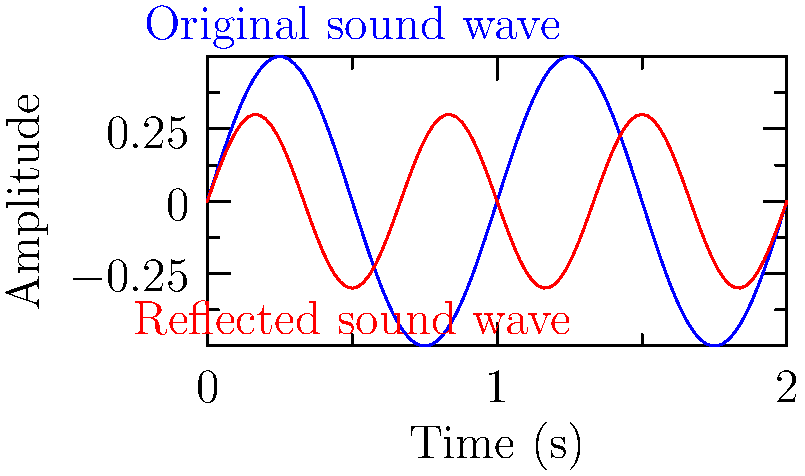In a theater, you're analyzing the acoustics represented by the sound wave diagram above. The blue wave represents the original sound, and the red wave represents the reflected sound. If the original sound has a frequency of 440 Hz, what is the frequency of the reflected sound wave? To solve this problem, we need to analyze the relationship between the two waves:

1. Observe that the blue wave (original sound) completes 2 full cycles in the given time frame.
2. The red wave (reflected sound) completes 3 full cycles in the same time frame.
3. The ratio of their frequencies will be proportional to the number of cycles completed:

   $\frac{f_{\text{reflected}}}{f_{\text{original}}} = \frac{3}{2}$

4. We know that $f_{\text{original}} = 440$ Hz, so we can set up the equation:

   $\frac{f_{\text{reflected}}}{440} = \frac{3}{2}$

5. Cross-multiply:

   $2f_{\text{reflected}} = 3 \times 440$

6. Solve for $f_{\text{reflected}}$:

   $f_{\text{reflected}} = \frac{3 \times 440}{2} = 660$ Hz

Therefore, the frequency of the reflected sound wave is 660 Hz.
Answer: 660 Hz 